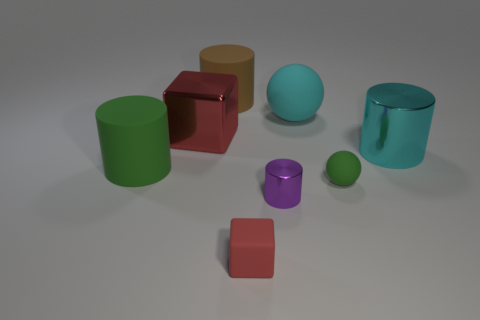Subtract all small metallic cylinders. How many cylinders are left? 3 Add 1 big red cubes. How many objects exist? 9 Subtract all spheres. How many objects are left? 6 Subtract all green cylinders. How many cylinders are left? 3 Subtract 1 balls. How many balls are left? 1 Subtract all green cylinders. Subtract all red spheres. How many cylinders are left? 3 Subtract all cyan cylinders. How many blue blocks are left? 0 Subtract all large brown matte spheres. Subtract all tiny green rubber things. How many objects are left? 7 Add 3 big metal objects. How many big metal objects are left? 5 Add 3 tiny green cylinders. How many tiny green cylinders exist? 3 